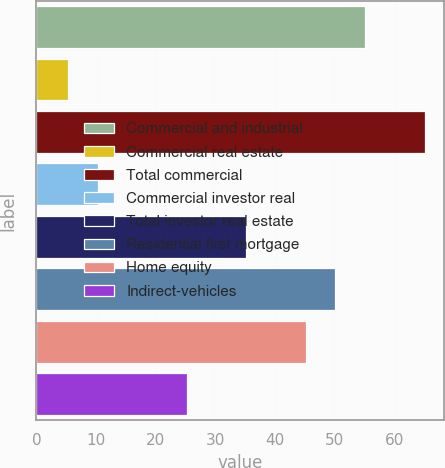Convert chart to OTSL. <chart><loc_0><loc_0><loc_500><loc_500><bar_chart><fcel>Commercial and industrial<fcel>Commercial real estate<fcel>Total commercial<fcel>Commercial investor real<fcel>Total investor real estate<fcel>Residential first mortgage<fcel>Home equity<fcel>Indirect-vehicles<nl><fcel>55.08<fcel>5.28<fcel>65.04<fcel>10.26<fcel>35.16<fcel>50.1<fcel>45.12<fcel>25.2<nl></chart> 